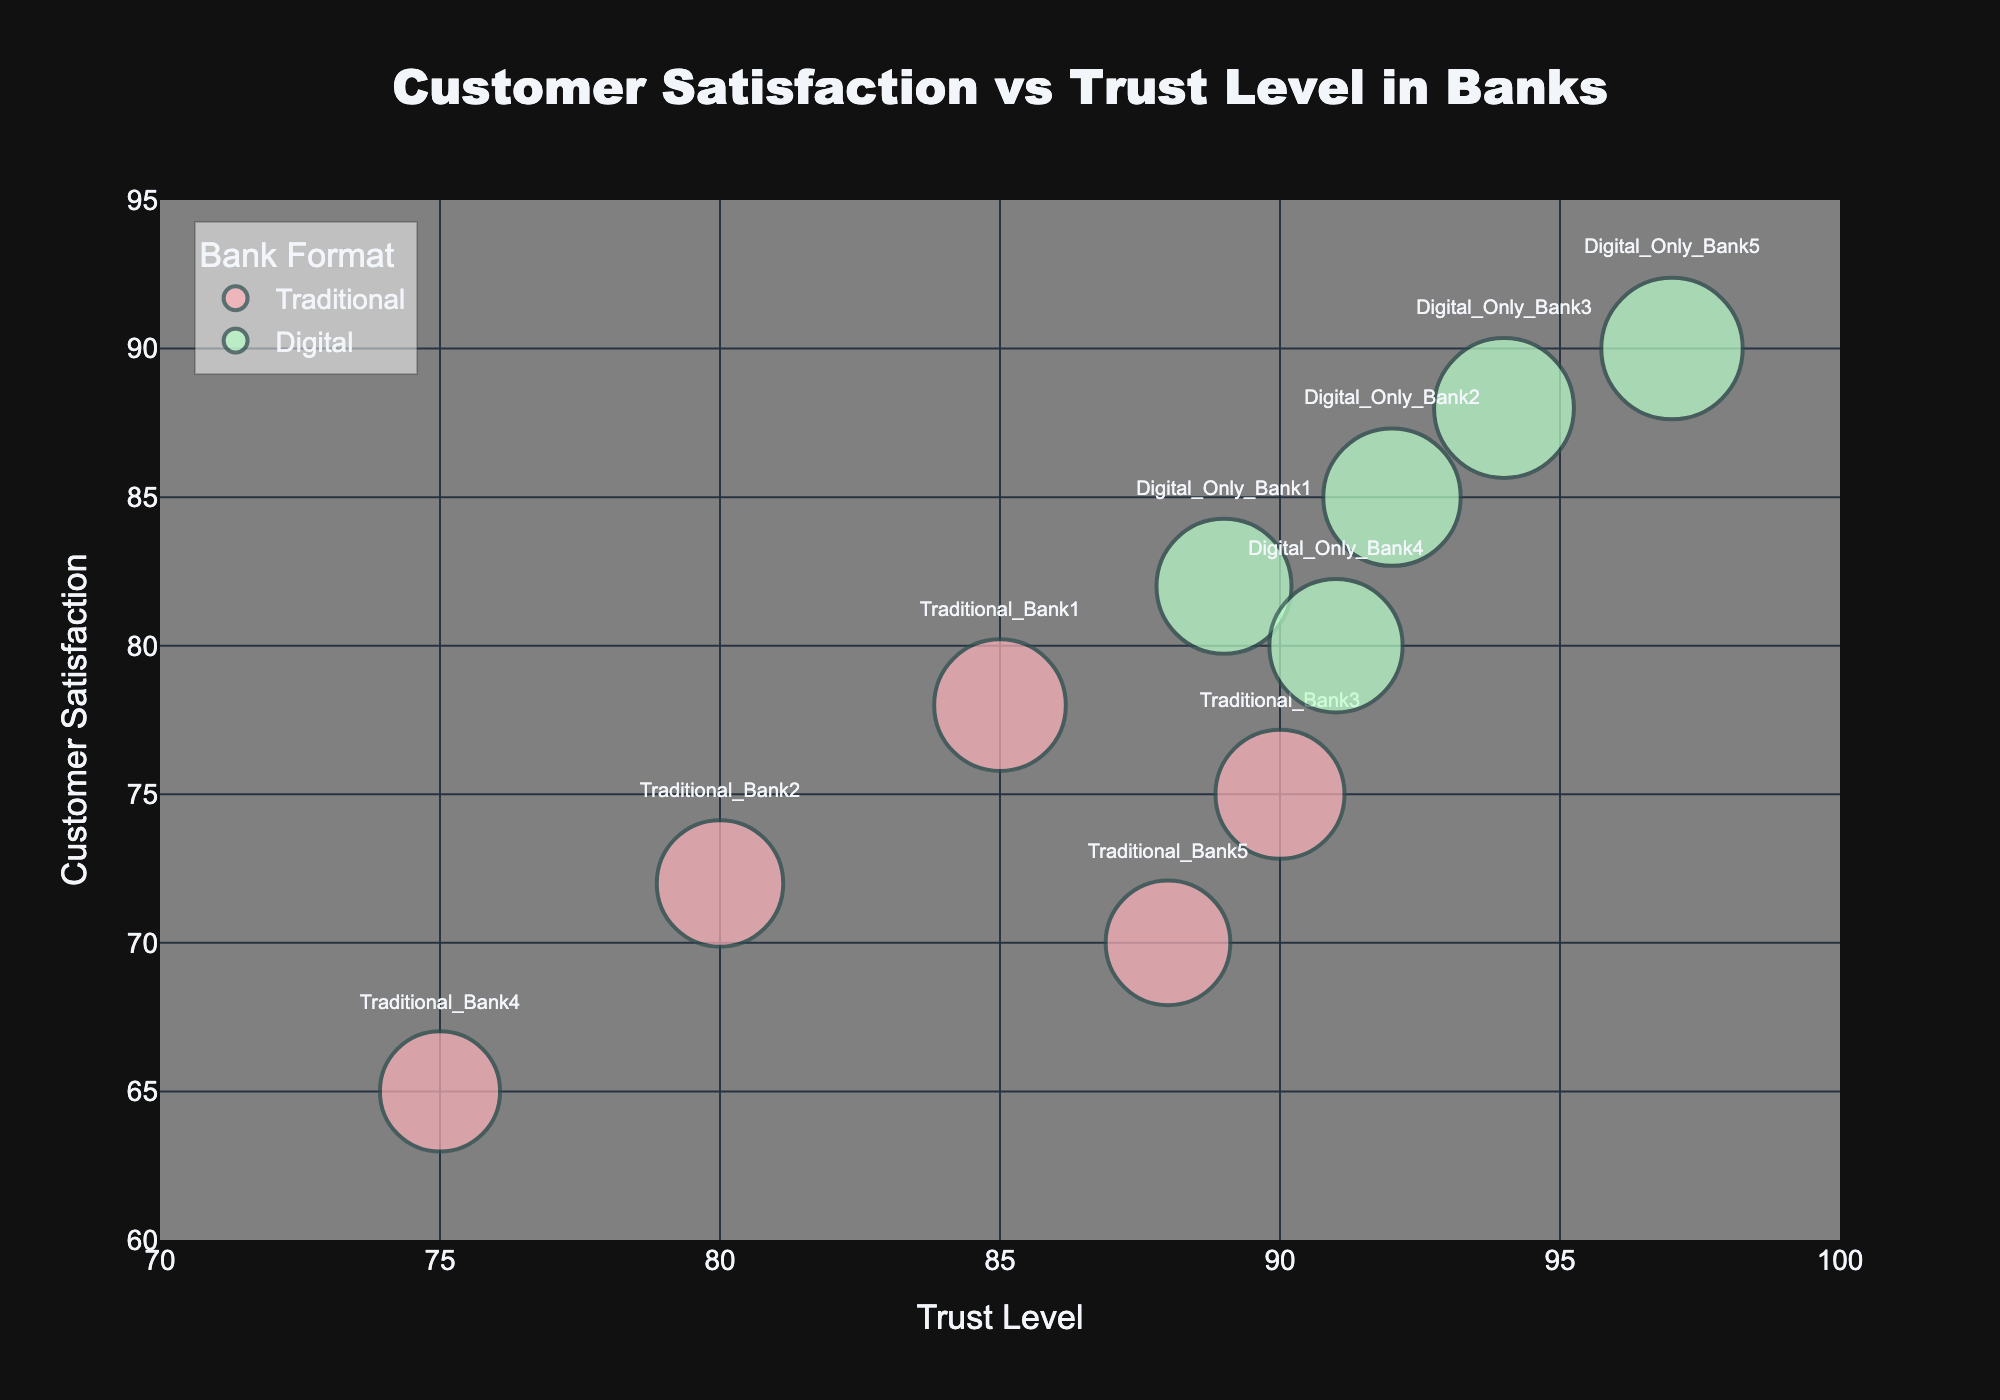How many traditional banks are represented in the figure? There are five datasets with the label "Traditional" in the "Format" column. By counting these data points, we see that there are 5 traditional banks.
Answer: 5 Which bank has the highest customer satisfaction level? By looking at the "Customer_Satisfaction" values on the y-axis, Digital_Only_Bank5 has the highest value at 90.
Answer: Digital_Only_Bank5 Which bank has the lowest trust level? By looking at the x-axis values, Traditional_Bank4 has the lowest trust level at 75.
Answer: Traditional_Bank4 What is the relationship between trust level and customer satisfaction in traditional banks? Traditional banks are shown as bubbles in a somewhat scattered arrangement. However, there is a slight upward trend indicating a positive correlation: higher trust levels generally correspond to higher customer satisfaction levels.
Answer: Positive Correlation How does the customer satisfaction of digital-only banks compare to traditional banks at the same trust level? By comparing the bubbles at the same trust levels for both types of banks, digital-only banks generally have higher customer satisfaction levels for comparable trust levels.
Answer: Digital-only banks have higher satisfaction Which traditional bank has the smallest bubble? The size of the bubble corresponds to customer satisfaction. Among traditional banks, Traditional_Bank4 has the smallest bubble since its customer satisfaction level is the lowest at 65.
Answer: Traditional_Bank4 Can you identify the bank with the highest trust level and describe its customer satisfaction? The highest trust level belongs to Digital_Only_Bank5 with a trust level of 97. Its customer satisfaction level is also the highest at 90.
Answer: Digital_Only_Bank5, 90 What's the average trust level of digital-only banks? The trust levels of the digital-only banks are 89, 92, 94, 91, and 97. The sum of these values is 463, and there are 5 digital-only banks, leading to an average trust level of 463 / 5 = 92.6.
Answer: 92.6 Which has a larger range of customer satisfaction levels: digital-only banks or traditional banks? The range is calculated as the difference between the highest and lowest customer satisfaction levels. For digital-only banks, the range is 90 - 80 = 10. For traditional banks, the range is 78 - 65 = 13. Thus, traditional banks have a larger range of customer satisfaction levels.
Answer: Traditional banks have a larger range What is the median customer satisfaction level for digital-only banks? Sorting the customer satisfaction levels of digital-only banks: 80, 82, 85, 88, 90. The middle value is 85, making it the median customer satisfaction level for digital-only banks.
Answer: 85 